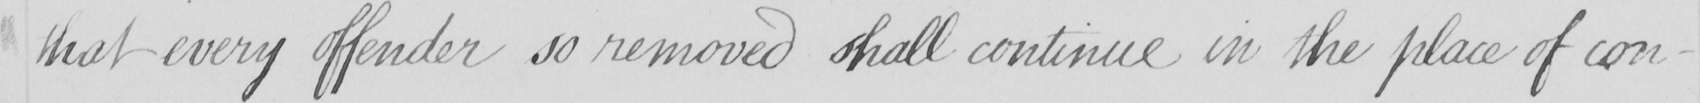Transcribe the text shown in this historical manuscript line. that every offender so removed shall continue in the place of con- 